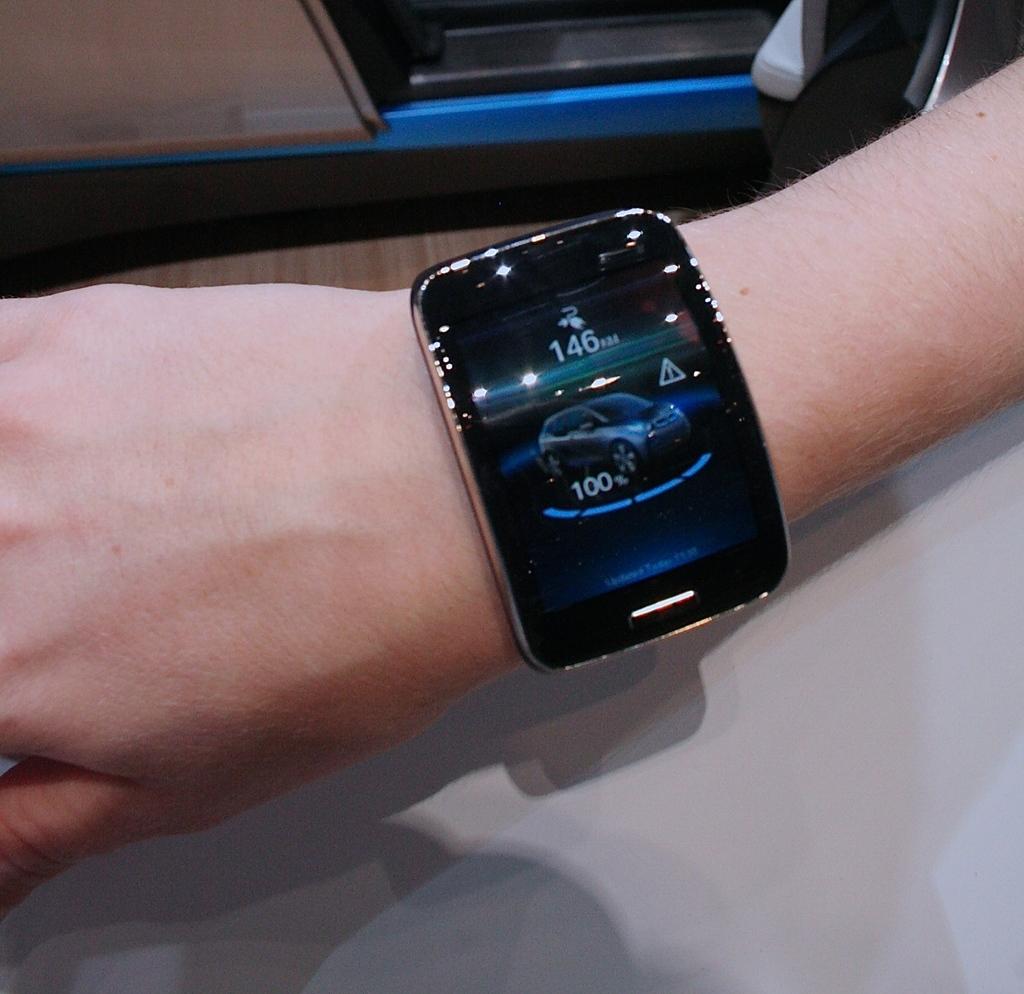What is the top number?
Give a very brief answer. 146. What time is displayed?
Provide a short and direct response. 1:46. 